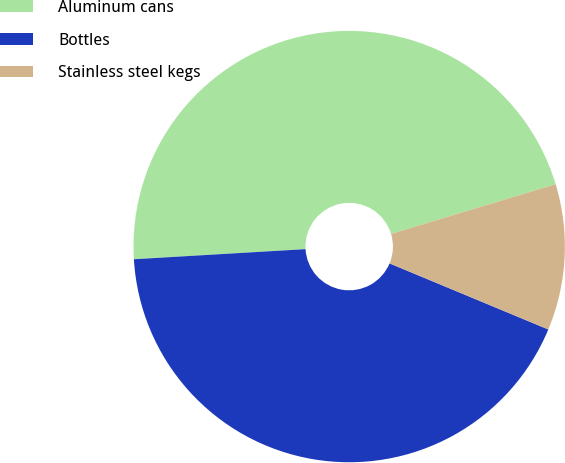Convert chart to OTSL. <chart><loc_0><loc_0><loc_500><loc_500><pie_chart><fcel>Aluminum cans<fcel>Bottles<fcel>Stainless steel kegs<nl><fcel>46.27%<fcel>42.79%<fcel>10.95%<nl></chart> 